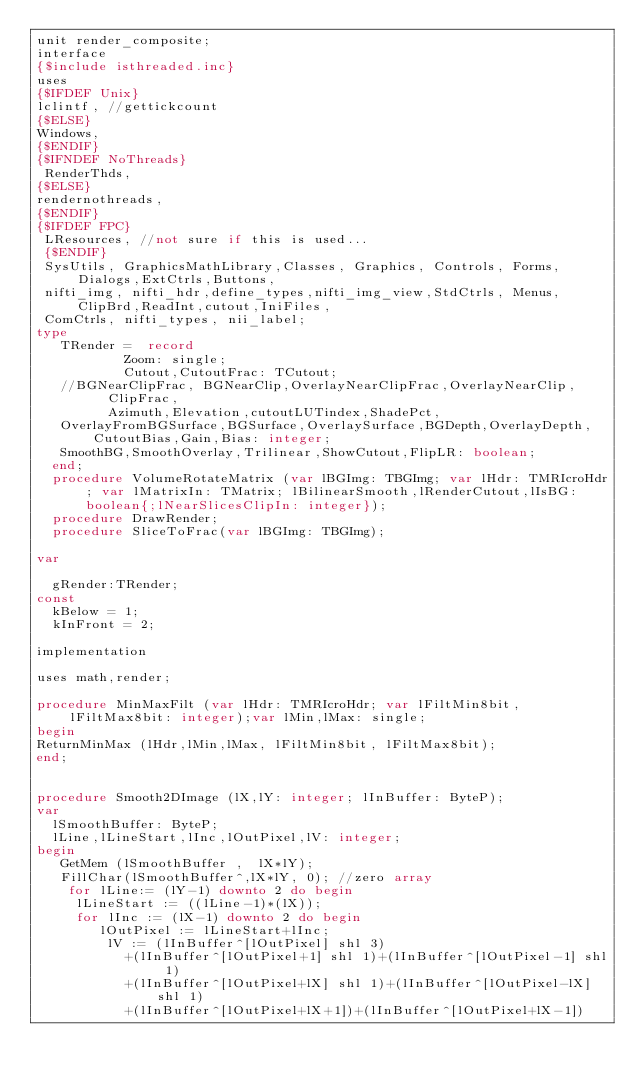<code> <loc_0><loc_0><loc_500><loc_500><_Pascal_>unit render_composite;
interface
{$include isthreaded.inc}
uses
{$IFDEF Unix}
lclintf, //gettickcount
{$ELSE}
Windows,
{$ENDIF}
{$IFNDEF NoThreads}
 RenderThds,
{$ELSE}
rendernothreads,
{$ENDIF}
{$IFDEF FPC}
 LResources, //not sure if this is used...
 {$ENDIF}
 SysUtils, GraphicsMathLibrary,Classes, Graphics, Controls, Forms, Dialogs,ExtCtrls,Buttons,
 nifti_img, nifti_hdr,define_types,nifti_img_view,StdCtrls, Menus,ClipBrd,ReadInt,cutout,IniFiles,
 ComCtrls, nifti_types, nii_label;
type
   TRender =  record
           Zoom: single;
           Cutout,CutoutFrac: TCutout;
	 //BGNearClipFrac, BGNearClip,OverlayNearClipFrac,OverlayNearClip,
         ClipFrac,
         Azimuth,Elevation,cutoutLUTindex,ShadePct,
	 OverlayFromBGSurface,BGSurface,OverlaySurface,BGDepth,OverlayDepth,CutoutBias,Gain,Bias: integer;
	 SmoothBG,SmoothOverlay,Trilinear,ShowCutout,FlipLR: boolean;
  end;
  procedure VolumeRotateMatrix (var lBGImg: TBGImg; var lHdr: TMRIcroHdr; var lMatrixIn: TMatrix; lBilinearSmooth,lRenderCutout,lIsBG: boolean{;lNearSlicesClipIn: integer});
  procedure DrawRender;
  procedure SliceToFrac(var lBGImg: TBGImg);

var

  gRender:TRender;
const
	kBelow = 1;
	kInFront = 2;

implementation

uses math,render;

procedure MinMaxFilt (var lHdr: TMRIcroHdr; var lFiltMin8bit, lFiltMax8bit: integer);var lMin,lMax: single;
begin
ReturnMinMax (lHdr,lMin,lMax, lFiltMin8bit, lFiltMax8bit);
end;


procedure Smooth2DImage (lX,lY: integer; lInBuffer: ByteP);
var
	lSmoothBuffer: ByteP;
	lLine,lLineStart,lInc,lOutPixel,lV: integer;
begin
	 GetMem (lSmoothBuffer ,  lX*lY);
	 FillChar(lSmoothBuffer^,lX*lY, 0); //zero array
	  for lLine:= (lY-1) downto 2 do begin
		 lLineStart := ((lLine-1)*(lX));
		 for lInc := (lX-1) downto 2 do begin
			  lOutPixel := lLineStart+lInc;
				 lV := (lInBuffer^[lOutPixel] shl 3)
				   +(lInBuffer^[lOutPixel+1] shl 1)+(lInBuffer^[lOutPixel-1] shl 1)
				   +(lInBuffer^[lOutPixel+lX] shl 1)+(lInBuffer^[lOutPixel-lX] shl 1)
				   +(lInBuffer^[lOutPixel+lX+1])+(lInBuffer^[lOutPixel+lX-1])</code> 